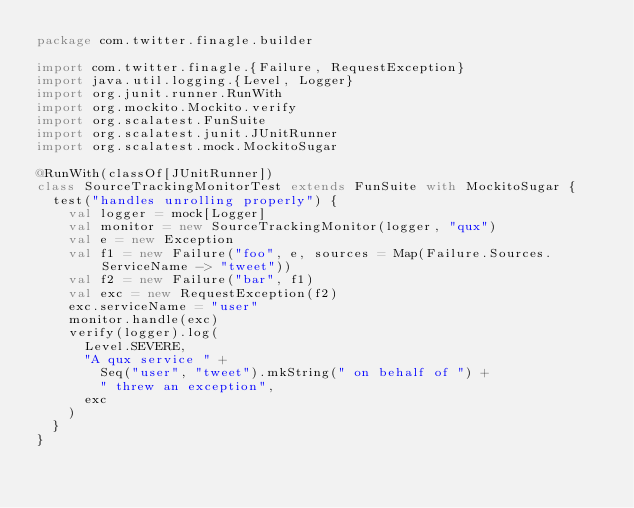<code> <loc_0><loc_0><loc_500><loc_500><_Scala_>package com.twitter.finagle.builder

import com.twitter.finagle.{Failure, RequestException}
import java.util.logging.{Level, Logger}
import org.junit.runner.RunWith
import org.mockito.Mockito.verify
import org.scalatest.FunSuite
import org.scalatest.junit.JUnitRunner
import org.scalatest.mock.MockitoSugar

@RunWith(classOf[JUnitRunner])
class SourceTrackingMonitorTest extends FunSuite with MockitoSugar {
  test("handles unrolling properly") {
    val logger = mock[Logger]
    val monitor = new SourceTrackingMonitor(logger, "qux")
    val e = new Exception
    val f1 = new Failure("foo", e, sources = Map(Failure.Sources.ServiceName -> "tweet"))
    val f2 = new Failure("bar", f1)
    val exc = new RequestException(f2)
    exc.serviceName = "user"
    monitor.handle(exc)
    verify(logger).log(
      Level.SEVERE,
      "A qux service " +
        Seq("user", "tweet").mkString(" on behalf of ") +
        " threw an exception",
      exc
    )
  }
}
</code> 